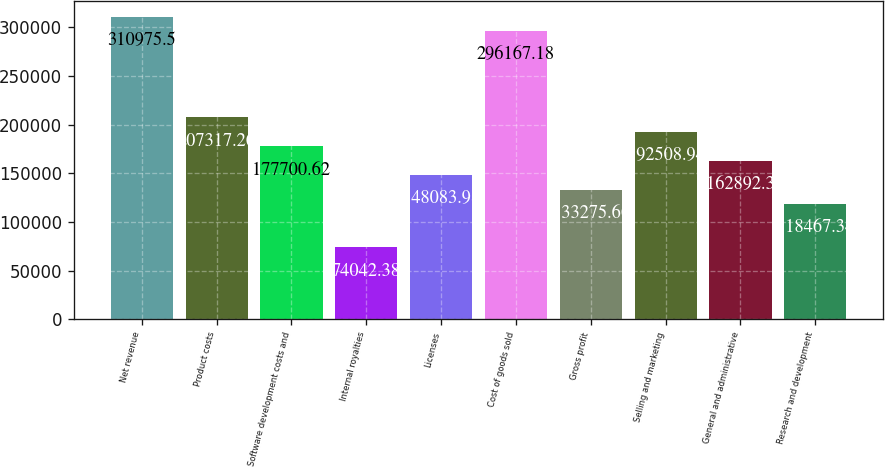Convert chart. <chart><loc_0><loc_0><loc_500><loc_500><bar_chart><fcel>Net revenue<fcel>Product costs<fcel>Software development costs and<fcel>Internal royalties<fcel>Licenses<fcel>Cost of goods sold<fcel>Gross profit<fcel>Selling and marketing<fcel>General and administrative<fcel>Research and development<nl><fcel>310976<fcel>207317<fcel>177701<fcel>74042.4<fcel>148084<fcel>296167<fcel>133276<fcel>192509<fcel>162892<fcel>118467<nl></chart> 